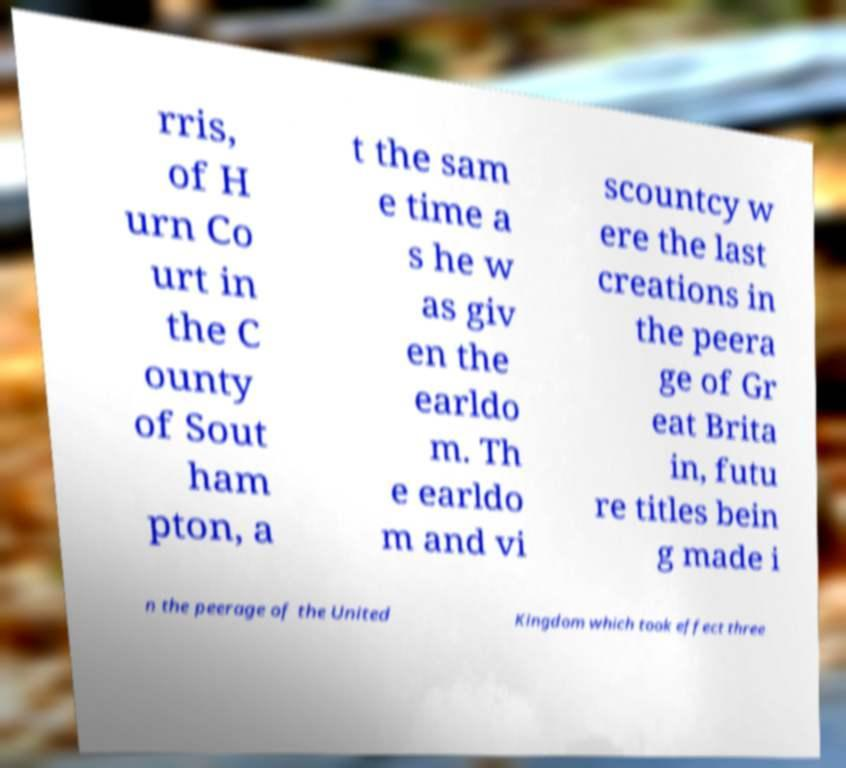Please identify and transcribe the text found in this image. rris, of H urn Co urt in the C ounty of Sout ham pton, a t the sam e time a s he w as giv en the earldo m. Th e earldo m and vi scountcy w ere the last creations in the peera ge of Gr eat Brita in, futu re titles bein g made i n the peerage of the United Kingdom which took effect three 